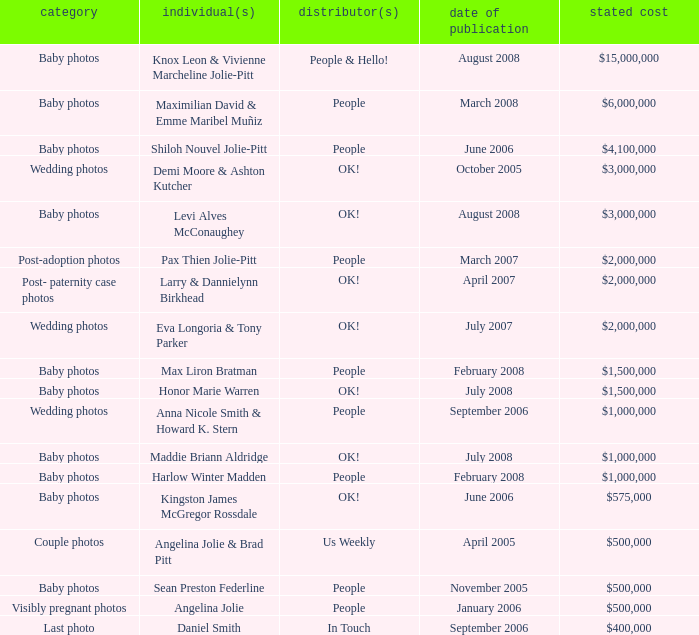What was the publication date of the photos of Sean Preston Federline that cost $500,000 and were published by People? November 2005. 